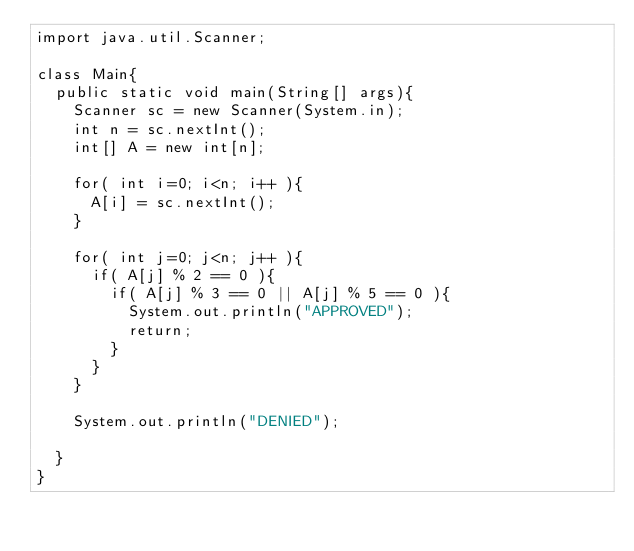<code> <loc_0><loc_0><loc_500><loc_500><_Java_>import java.util.Scanner;

class Main{
  public static void main(String[] args){
    Scanner sc = new Scanner(System.in);
    int n = sc.nextInt();
    int[] A = new int[n];
    
    for( int i=0; i<n; i++ ){
      A[i] = sc.nextInt();
    }
    
    for( int j=0; j<n; j++ ){
      if( A[j] % 2 == 0 ){
        if( A[j] % 3 == 0 || A[j] % 5 == 0 ){
          System.out.println("APPROVED");
          return;
        }
      }
    }
    
    System.out.println("DENIED");
    
  }
}
</code> 